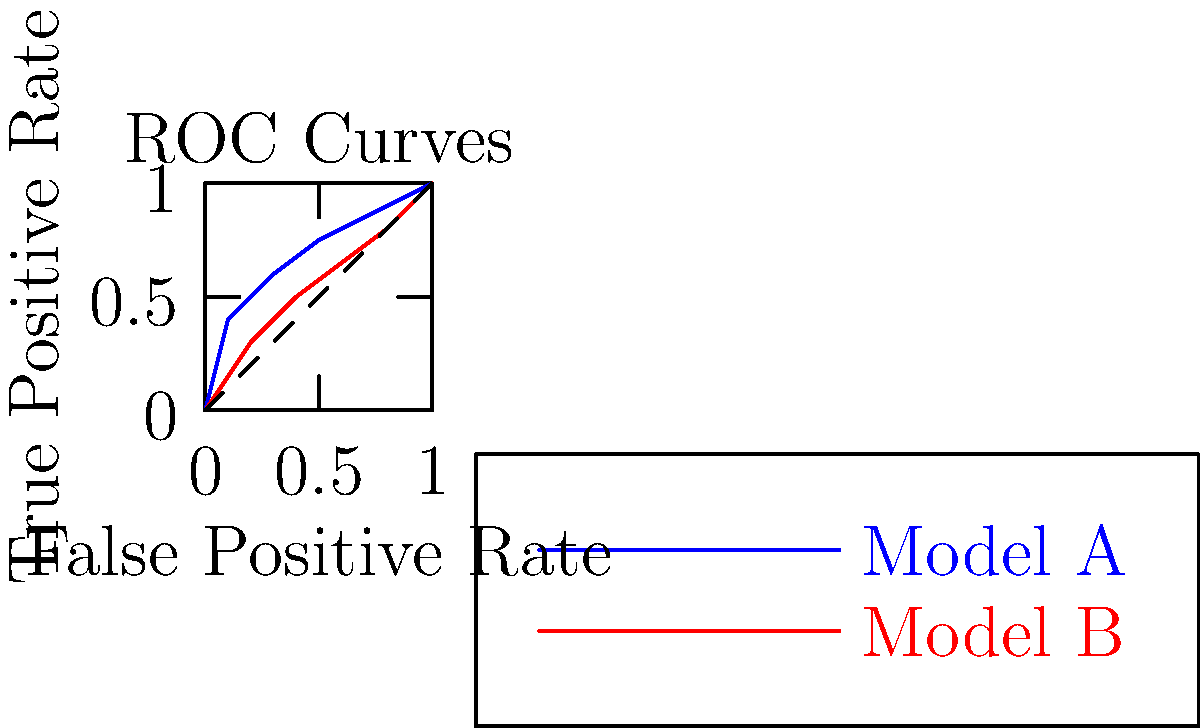Given the ROC curves for two machine learning models (A and B) as shown in the graph, which model demonstrates superior performance in terms of classification? Justify your answer using the Area Under the Curve (AUC) concept. To determine which model performs better, we need to analyze the ROC curves and consider the Area Under the Curve (AUC) for each model. Let's break this down step-by-step:

1. ROC Curve interpretation:
   - The ROC curve plots the True Positive Rate (TPR) against the False Positive Rate (FPR) at various threshold settings.
   - A model with perfect classification would have a curve that passes through the top-left corner (0,1).

2. Comparing the curves:
   - Model A (blue curve) is consistently above Model B (red curve).
   - This indicates that for any given FPR, Model A achieves a higher TPR than Model B.

3. Area Under the Curve (AUC):
   - The AUC represents the degree of separability between classes.
   - AUC ranges from 0 to 1, where 1 represents perfect classification.
   - A higher AUC indicates better model performance.

4. Estimating AUC from the graph:
   - Model A has a larger area under its curve compared to Model B.
   - Model A's curve is closer to the top-left corner, indicating a higher AUC.

5. Interpretation of AUC:
   - A larger AUC suggests that Model A has a higher probability of ranking a randomly chosen positive instance higher than a randomly chosen negative instance, compared to Model B.

Based on these observations, we can conclude that Model A demonstrates superior performance in terms of classification compared to Model B, as evidenced by its higher AUC.
Answer: Model A, due to higher AUC 